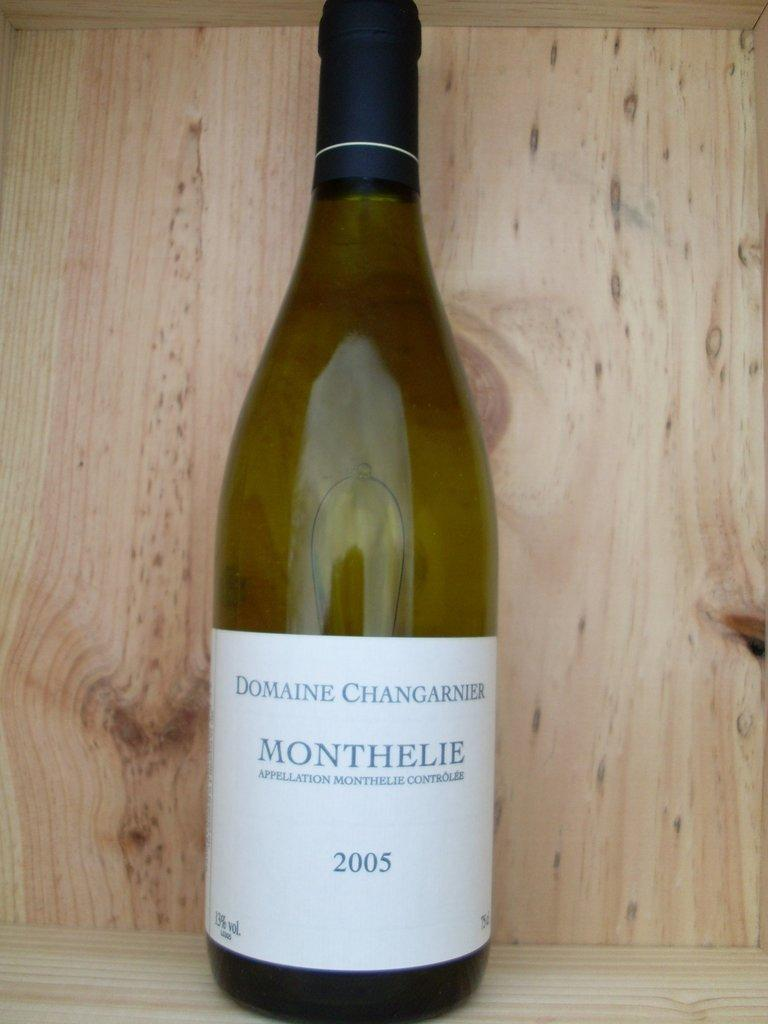<image>
Relay a brief, clear account of the picture shown. A bottled of wine called Monthelie that was bottled in 2005. 